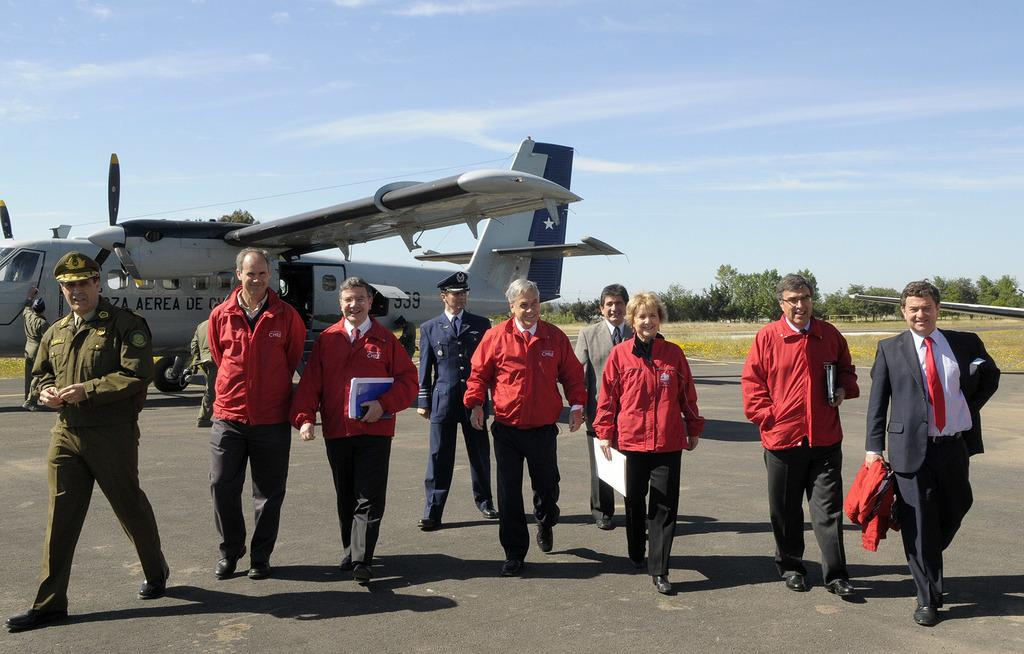What can be seen in the image? There is a group of men and women in the image. What are the people in the image wearing? The group of people are wearing red color jackets. Where are the people in the image coming from? The group of people are coming from an aircraft. What is the color of the aircraft in the image? There is a silver color aircraft in the image. What can be seen in the background of the image? There are trees visible in the background of the image. What type of pet can be seen in the image? There is no pet visible in the image. What is the group of people using to stick the jackets together? There is no glue or any indication of sticking jackets together in the image. 